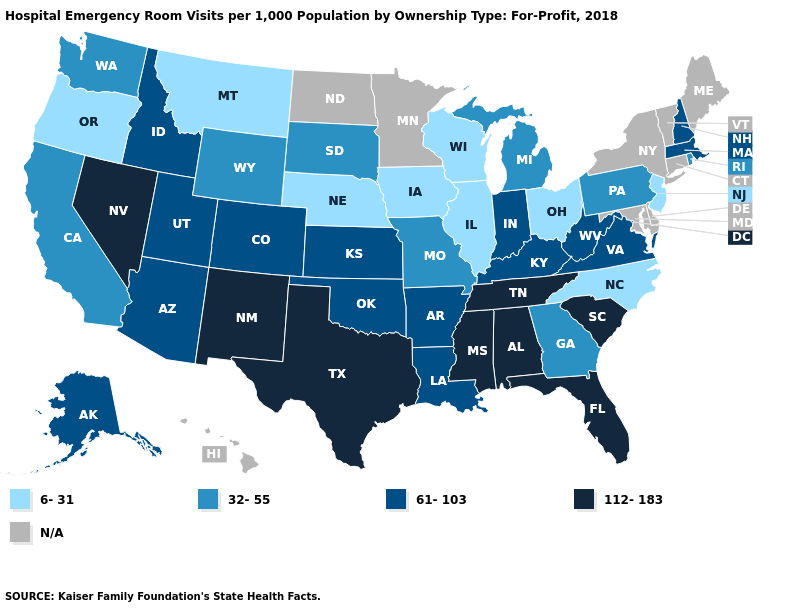Name the states that have a value in the range 32-55?
Be succinct. California, Georgia, Michigan, Missouri, Pennsylvania, Rhode Island, South Dakota, Washington, Wyoming. Name the states that have a value in the range 61-103?
Give a very brief answer. Alaska, Arizona, Arkansas, Colorado, Idaho, Indiana, Kansas, Kentucky, Louisiana, Massachusetts, New Hampshire, Oklahoma, Utah, Virginia, West Virginia. Which states have the highest value in the USA?
Be succinct. Alabama, Florida, Mississippi, Nevada, New Mexico, South Carolina, Tennessee, Texas. What is the lowest value in the South?
Write a very short answer. 6-31. Which states hav the highest value in the South?
Write a very short answer. Alabama, Florida, Mississippi, South Carolina, Tennessee, Texas. Is the legend a continuous bar?
Write a very short answer. No. Name the states that have a value in the range 61-103?
Write a very short answer. Alaska, Arizona, Arkansas, Colorado, Idaho, Indiana, Kansas, Kentucky, Louisiana, Massachusetts, New Hampshire, Oklahoma, Utah, Virginia, West Virginia. Does the first symbol in the legend represent the smallest category?
Keep it brief. Yes. Which states have the highest value in the USA?
Quick response, please. Alabama, Florida, Mississippi, Nevada, New Mexico, South Carolina, Tennessee, Texas. How many symbols are there in the legend?
Be succinct. 5. Which states have the lowest value in the MidWest?
Concise answer only. Illinois, Iowa, Nebraska, Ohio, Wisconsin. Among the states that border North Dakota , which have the highest value?
Give a very brief answer. South Dakota. Name the states that have a value in the range 61-103?
Be succinct. Alaska, Arizona, Arkansas, Colorado, Idaho, Indiana, Kansas, Kentucky, Louisiana, Massachusetts, New Hampshire, Oklahoma, Utah, Virginia, West Virginia. Name the states that have a value in the range 32-55?
Keep it brief. California, Georgia, Michigan, Missouri, Pennsylvania, Rhode Island, South Dakota, Washington, Wyoming. 